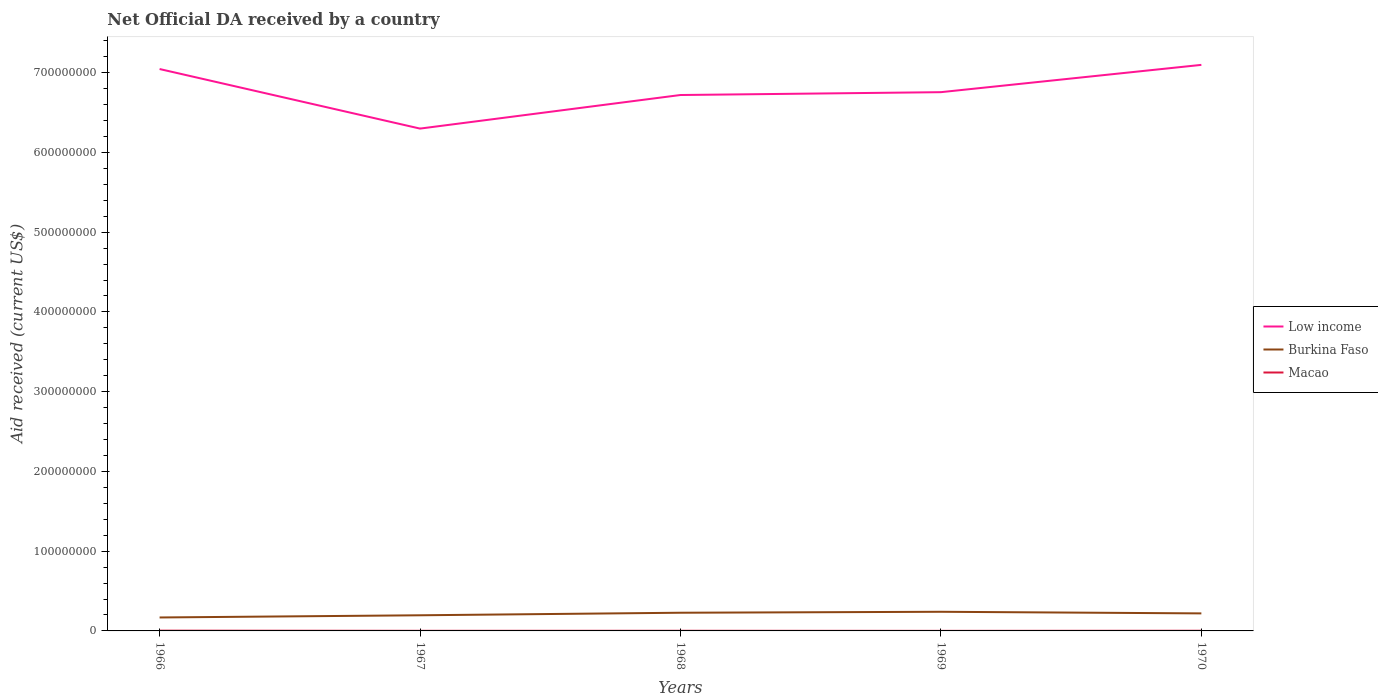How many different coloured lines are there?
Provide a short and direct response. 3. Does the line corresponding to Burkina Faso intersect with the line corresponding to Macao?
Make the answer very short. No. In which year was the net official development assistance aid received in Burkina Faso maximum?
Make the answer very short. 1966. What is the total net official development assistance aid received in Burkina Faso in the graph?
Your response must be concise. -1.19e+06. What is the difference between the highest and the second highest net official development assistance aid received in Low income?
Offer a terse response. 7.99e+07. What is the difference between the highest and the lowest net official development assistance aid received in Burkina Faso?
Your response must be concise. 3. Is the net official development assistance aid received in Burkina Faso strictly greater than the net official development assistance aid received in Low income over the years?
Offer a very short reply. Yes. How many years are there in the graph?
Your answer should be very brief. 5. What is the difference between two consecutive major ticks on the Y-axis?
Provide a short and direct response. 1.00e+08. Are the values on the major ticks of Y-axis written in scientific E-notation?
Keep it short and to the point. No. Does the graph contain grids?
Make the answer very short. No. How are the legend labels stacked?
Give a very brief answer. Vertical. What is the title of the graph?
Make the answer very short. Net Official DA received by a country. Does "Jamaica" appear as one of the legend labels in the graph?
Make the answer very short. No. What is the label or title of the Y-axis?
Your answer should be compact. Aid received (current US$). What is the Aid received (current US$) of Low income in 1966?
Offer a terse response. 7.05e+08. What is the Aid received (current US$) of Burkina Faso in 1966?
Provide a short and direct response. 1.69e+07. What is the Aid received (current US$) in Low income in 1967?
Offer a terse response. 6.30e+08. What is the Aid received (current US$) of Burkina Faso in 1967?
Ensure brevity in your answer.  1.96e+07. What is the Aid received (current US$) in Macao in 1967?
Your answer should be compact. 1.40e+05. What is the Aid received (current US$) of Low income in 1968?
Ensure brevity in your answer.  6.72e+08. What is the Aid received (current US$) in Burkina Faso in 1968?
Make the answer very short. 2.28e+07. What is the Aid received (current US$) in Low income in 1969?
Offer a terse response. 6.76e+08. What is the Aid received (current US$) of Burkina Faso in 1969?
Ensure brevity in your answer.  2.40e+07. What is the Aid received (current US$) of Low income in 1970?
Offer a terse response. 7.10e+08. What is the Aid received (current US$) in Burkina Faso in 1970?
Your response must be concise. 2.20e+07. Across all years, what is the maximum Aid received (current US$) in Low income?
Ensure brevity in your answer.  7.10e+08. Across all years, what is the maximum Aid received (current US$) in Burkina Faso?
Keep it short and to the point. 2.40e+07. Across all years, what is the maximum Aid received (current US$) in Macao?
Offer a terse response. 3.40e+05. Across all years, what is the minimum Aid received (current US$) in Low income?
Provide a short and direct response. 6.30e+08. Across all years, what is the minimum Aid received (current US$) in Burkina Faso?
Provide a short and direct response. 1.69e+07. What is the total Aid received (current US$) of Low income in the graph?
Give a very brief answer. 3.39e+09. What is the total Aid received (current US$) in Burkina Faso in the graph?
Make the answer very short. 1.05e+08. What is the total Aid received (current US$) of Macao in the graph?
Keep it short and to the point. 9.30e+05. What is the difference between the Aid received (current US$) in Low income in 1966 and that in 1967?
Your response must be concise. 7.47e+07. What is the difference between the Aid received (current US$) of Burkina Faso in 1966 and that in 1967?
Ensure brevity in your answer.  -2.76e+06. What is the difference between the Aid received (current US$) in Low income in 1966 and that in 1968?
Give a very brief answer. 3.26e+07. What is the difference between the Aid received (current US$) of Burkina Faso in 1966 and that in 1968?
Your answer should be compact. -5.95e+06. What is the difference between the Aid received (current US$) of Low income in 1966 and that in 1969?
Your answer should be very brief. 2.90e+07. What is the difference between the Aid received (current US$) of Burkina Faso in 1966 and that in 1969?
Ensure brevity in your answer.  -7.14e+06. What is the difference between the Aid received (current US$) in Low income in 1966 and that in 1970?
Provide a short and direct response. -5.20e+06. What is the difference between the Aid received (current US$) in Burkina Faso in 1966 and that in 1970?
Provide a succinct answer. -5.13e+06. What is the difference between the Aid received (current US$) of Low income in 1967 and that in 1968?
Offer a very short reply. -4.21e+07. What is the difference between the Aid received (current US$) of Burkina Faso in 1967 and that in 1968?
Make the answer very short. -3.19e+06. What is the difference between the Aid received (current US$) of Macao in 1967 and that in 1968?
Your response must be concise. -3.00e+04. What is the difference between the Aid received (current US$) of Low income in 1967 and that in 1969?
Make the answer very short. -4.57e+07. What is the difference between the Aid received (current US$) in Burkina Faso in 1967 and that in 1969?
Offer a terse response. -4.38e+06. What is the difference between the Aid received (current US$) in Low income in 1967 and that in 1970?
Ensure brevity in your answer.  -7.99e+07. What is the difference between the Aid received (current US$) in Burkina Faso in 1967 and that in 1970?
Make the answer very short. -2.37e+06. What is the difference between the Aid received (current US$) of Low income in 1968 and that in 1969?
Provide a short and direct response. -3.57e+06. What is the difference between the Aid received (current US$) of Burkina Faso in 1968 and that in 1969?
Offer a terse response. -1.19e+06. What is the difference between the Aid received (current US$) in Low income in 1968 and that in 1970?
Ensure brevity in your answer.  -3.78e+07. What is the difference between the Aid received (current US$) in Burkina Faso in 1968 and that in 1970?
Your answer should be compact. 8.20e+05. What is the difference between the Aid received (current US$) in Low income in 1969 and that in 1970?
Offer a very short reply. -3.42e+07. What is the difference between the Aid received (current US$) in Burkina Faso in 1969 and that in 1970?
Your answer should be very brief. 2.01e+06. What is the difference between the Aid received (current US$) of Low income in 1966 and the Aid received (current US$) of Burkina Faso in 1967?
Offer a very short reply. 6.85e+08. What is the difference between the Aid received (current US$) in Low income in 1966 and the Aid received (current US$) in Macao in 1967?
Give a very brief answer. 7.04e+08. What is the difference between the Aid received (current US$) in Burkina Faso in 1966 and the Aid received (current US$) in Macao in 1967?
Ensure brevity in your answer.  1.67e+07. What is the difference between the Aid received (current US$) in Low income in 1966 and the Aid received (current US$) in Burkina Faso in 1968?
Provide a short and direct response. 6.82e+08. What is the difference between the Aid received (current US$) in Low income in 1966 and the Aid received (current US$) in Macao in 1968?
Your response must be concise. 7.04e+08. What is the difference between the Aid received (current US$) in Burkina Faso in 1966 and the Aid received (current US$) in Macao in 1968?
Ensure brevity in your answer.  1.67e+07. What is the difference between the Aid received (current US$) of Low income in 1966 and the Aid received (current US$) of Burkina Faso in 1969?
Your answer should be very brief. 6.81e+08. What is the difference between the Aid received (current US$) of Low income in 1966 and the Aid received (current US$) of Macao in 1969?
Your response must be concise. 7.04e+08. What is the difference between the Aid received (current US$) in Burkina Faso in 1966 and the Aid received (current US$) in Macao in 1969?
Offer a terse response. 1.68e+07. What is the difference between the Aid received (current US$) in Low income in 1966 and the Aid received (current US$) in Burkina Faso in 1970?
Provide a succinct answer. 6.83e+08. What is the difference between the Aid received (current US$) of Low income in 1966 and the Aid received (current US$) of Macao in 1970?
Make the answer very short. 7.04e+08. What is the difference between the Aid received (current US$) of Burkina Faso in 1966 and the Aid received (current US$) of Macao in 1970?
Give a very brief answer. 1.66e+07. What is the difference between the Aid received (current US$) of Low income in 1967 and the Aid received (current US$) of Burkina Faso in 1968?
Give a very brief answer. 6.07e+08. What is the difference between the Aid received (current US$) in Low income in 1967 and the Aid received (current US$) in Macao in 1968?
Provide a short and direct response. 6.30e+08. What is the difference between the Aid received (current US$) in Burkina Faso in 1967 and the Aid received (current US$) in Macao in 1968?
Provide a short and direct response. 1.94e+07. What is the difference between the Aid received (current US$) in Low income in 1967 and the Aid received (current US$) in Burkina Faso in 1969?
Your answer should be compact. 6.06e+08. What is the difference between the Aid received (current US$) of Low income in 1967 and the Aid received (current US$) of Macao in 1969?
Your answer should be compact. 6.30e+08. What is the difference between the Aid received (current US$) of Burkina Faso in 1967 and the Aid received (current US$) of Macao in 1969?
Make the answer very short. 1.96e+07. What is the difference between the Aid received (current US$) of Low income in 1967 and the Aid received (current US$) of Burkina Faso in 1970?
Your answer should be compact. 6.08e+08. What is the difference between the Aid received (current US$) of Low income in 1967 and the Aid received (current US$) of Macao in 1970?
Give a very brief answer. 6.30e+08. What is the difference between the Aid received (current US$) in Burkina Faso in 1967 and the Aid received (current US$) in Macao in 1970?
Offer a very short reply. 1.94e+07. What is the difference between the Aid received (current US$) in Low income in 1968 and the Aid received (current US$) in Burkina Faso in 1969?
Your answer should be very brief. 6.48e+08. What is the difference between the Aid received (current US$) in Low income in 1968 and the Aid received (current US$) in Macao in 1969?
Provide a short and direct response. 6.72e+08. What is the difference between the Aid received (current US$) of Burkina Faso in 1968 and the Aid received (current US$) of Macao in 1969?
Your answer should be very brief. 2.27e+07. What is the difference between the Aid received (current US$) in Low income in 1968 and the Aid received (current US$) in Burkina Faso in 1970?
Provide a succinct answer. 6.50e+08. What is the difference between the Aid received (current US$) of Low income in 1968 and the Aid received (current US$) of Macao in 1970?
Offer a very short reply. 6.72e+08. What is the difference between the Aid received (current US$) in Burkina Faso in 1968 and the Aid received (current US$) in Macao in 1970?
Provide a succinct answer. 2.26e+07. What is the difference between the Aid received (current US$) in Low income in 1969 and the Aid received (current US$) in Burkina Faso in 1970?
Keep it short and to the point. 6.54e+08. What is the difference between the Aid received (current US$) in Low income in 1969 and the Aid received (current US$) in Macao in 1970?
Ensure brevity in your answer.  6.75e+08. What is the difference between the Aid received (current US$) of Burkina Faso in 1969 and the Aid received (current US$) of Macao in 1970?
Ensure brevity in your answer.  2.38e+07. What is the average Aid received (current US$) in Low income per year?
Your answer should be very brief. 6.78e+08. What is the average Aid received (current US$) in Burkina Faso per year?
Provide a short and direct response. 2.11e+07. What is the average Aid received (current US$) in Macao per year?
Your response must be concise. 1.86e+05. In the year 1966, what is the difference between the Aid received (current US$) in Low income and Aid received (current US$) in Burkina Faso?
Ensure brevity in your answer.  6.88e+08. In the year 1966, what is the difference between the Aid received (current US$) of Low income and Aid received (current US$) of Macao?
Provide a succinct answer. 7.04e+08. In the year 1966, what is the difference between the Aid received (current US$) in Burkina Faso and Aid received (current US$) in Macao?
Your response must be concise. 1.65e+07. In the year 1967, what is the difference between the Aid received (current US$) of Low income and Aid received (current US$) of Burkina Faso?
Offer a very short reply. 6.10e+08. In the year 1967, what is the difference between the Aid received (current US$) in Low income and Aid received (current US$) in Macao?
Provide a succinct answer. 6.30e+08. In the year 1967, what is the difference between the Aid received (current US$) in Burkina Faso and Aid received (current US$) in Macao?
Make the answer very short. 1.95e+07. In the year 1968, what is the difference between the Aid received (current US$) in Low income and Aid received (current US$) in Burkina Faso?
Give a very brief answer. 6.49e+08. In the year 1968, what is the difference between the Aid received (current US$) in Low income and Aid received (current US$) in Macao?
Give a very brief answer. 6.72e+08. In the year 1968, what is the difference between the Aid received (current US$) of Burkina Faso and Aid received (current US$) of Macao?
Offer a terse response. 2.26e+07. In the year 1969, what is the difference between the Aid received (current US$) in Low income and Aid received (current US$) in Burkina Faso?
Give a very brief answer. 6.52e+08. In the year 1969, what is the difference between the Aid received (current US$) in Low income and Aid received (current US$) in Macao?
Provide a short and direct response. 6.75e+08. In the year 1969, what is the difference between the Aid received (current US$) in Burkina Faso and Aid received (current US$) in Macao?
Offer a terse response. 2.39e+07. In the year 1970, what is the difference between the Aid received (current US$) of Low income and Aid received (current US$) of Burkina Faso?
Ensure brevity in your answer.  6.88e+08. In the year 1970, what is the difference between the Aid received (current US$) of Low income and Aid received (current US$) of Macao?
Your answer should be very brief. 7.10e+08. In the year 1970, what is the difference between the Aid received (current US$) of Burkina Faso and Aid received (current US$) of Macao?
Ensure brevity in your answer.  2.18e+07. What is the ratio of the Aid received (current US$) in Low income in 1966 to that in 1967?
Provide a succinct answer. 1.12. What is the ratio of the Aid received (current US$) of Burkina Faso in 1966 to that in 1967?
Your response must be concise. 0.86. What is the ratio of the Aid received (current US$) of Macao in 1966 to that in 1967?
Offer a very short reply. 2.43. What is the ratio of the Aid received (current US$) in Low income in 1966 to that in 1968?
Keep it short and to the point. 1.05. What is the ratio of the Aid received (current US$) of Burkina Faso in 1966 to that in 1968?
Make the answer very short. 0.74. What is the ratio of the Aid received (current US$) of Low income in 1966 to that in 1969?
Provide a short and direct response. 1.04. What is the ratio of the Aid received (current US$) of Burkina Faso in 1966 to that in 1969?
Provide a succinct answer. 0.7. What is the ratio of the Aid received (current US$) of Macao in 1966 to that in 1969?
Provide a short and direct response. 4.86. What is the ratio of the Aid received (current US$) in Low income in 1966 to that in 1970?
Offer a terse response. 0.99. What is the ratio of the Aid received (current US$) of Burkina Faso in 1966 to that in 1970?
Offer a terse response. 0.77. What is the ratio of the Aid received (current US$) of Macao in 1966 to that in 1970?
Ensure brevity in your answer.  1.62. What is the ratio of the Aid received (current US$) in Low income in 1967 to that in 1968?
Keep it short and to the point. 0.94. What is the ratio of the Aid received (current US$) in Burkina Faso in 1967 to that in 1968?
Provide a succinct answer. 0.86. What is the ratio of the Aid received (current US$) of Macao in 1967 to that in 1968?
Give a very brief answer. 0.82. What is the ratio of the Aid received (current US$) in Low income in 1967 to that in 1969?
Your answer should be very brief. 0.93. What is the ratio of the Aid received (current US$) in Burkina Faso in 1967 to that in 1969?
Your answer should be compact. 0.82. What is the ratio of the Aid received (current US$) of Low income in 1967 to that in 1970?
Your response must be concise. 0.89. What is the ratio of the Aid received (current US$) of Burkina Faso in 1967 to that in 1970?
Give a very brief answer. 0.89. What is the ratio of the Aid received (current US$) of Macao in 1967 to that in 1970?
Provide a short and direct response. 0.67. What is the ratio of the Aid received (current US$) in Burkina Faso in 1968 to that in 1969?
Your answer should be compact. 0.95. What is the ratio of the Aid received (current US$) of Macao in 1968 to that in 1969?
Your answer should be very brief. 2.43. What is the ratio of the Aid received (current US$) in Low income in 1968 to that in 1970?
Your answer should be compact. 0.95. What is the ratio of the Aid received (current US$) in Burkina Faso in 1968 to that in 1970?
Keep it short and to the point. 1.04. What is the ratio of the Aid received (current US$) in Macao in 1968 to that in 1970?
Make the answer very short. 0.81. What is the ratio of the Aid received (current US$) in Low income in 1969 to that in 1970?
Keep it short and to the point. 0.95. What is the ratio of the Aid received (current US$) of Burkina Faso in 1969 to that in 1970?
Make the answer very short. 1.09. What is the difference between the highest and the second highest Aid received (current US$) of Low income?
Your answer should be compact. 5.20e+06. What is the difference between the highest and the second highest Aid received (current US$) in Burkina Faso?
Give a very brief answer. 1.19e+06. What is the difference between the highest and the second highest Aid received (current US$) in Macao?
Ensure brevity in your answer.  1.30e+05. What is the difference between the highest and the lowest Aid received (current US$) of Low income?
Provide a succinct answer. 7.99e+07. What is the difference between the highest and the lowest Aid received (current US$) in Burkina Faso?
Provide a succinct answer. 7.14e+06. What is the difference between the highest and the lowest Aid received (current US$) in Macao?
Your answer should be compact. 2.70e+05. 